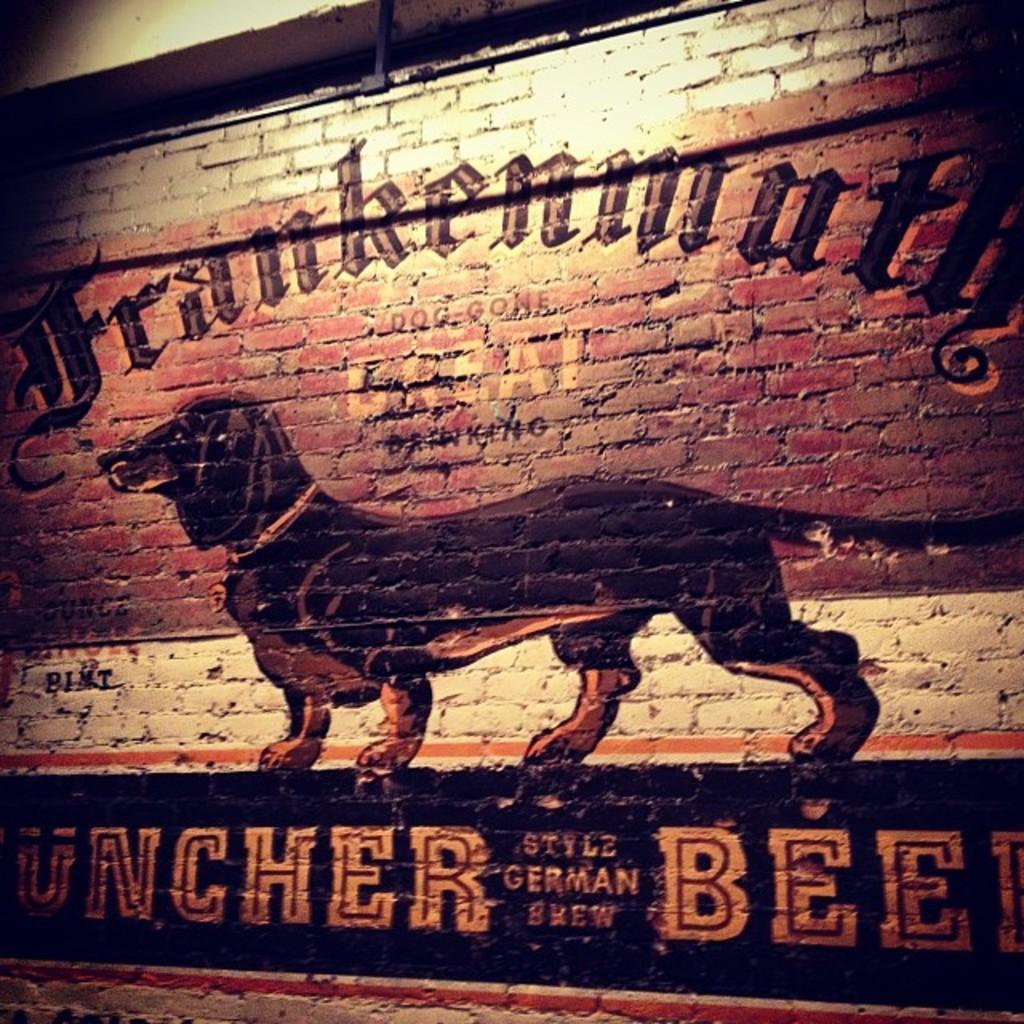Describe this image in one or two sentences. In the image we can see there is a painting on the wall of a dog standing and there is matter written on the wall. The wall is made up of stone bricks. 